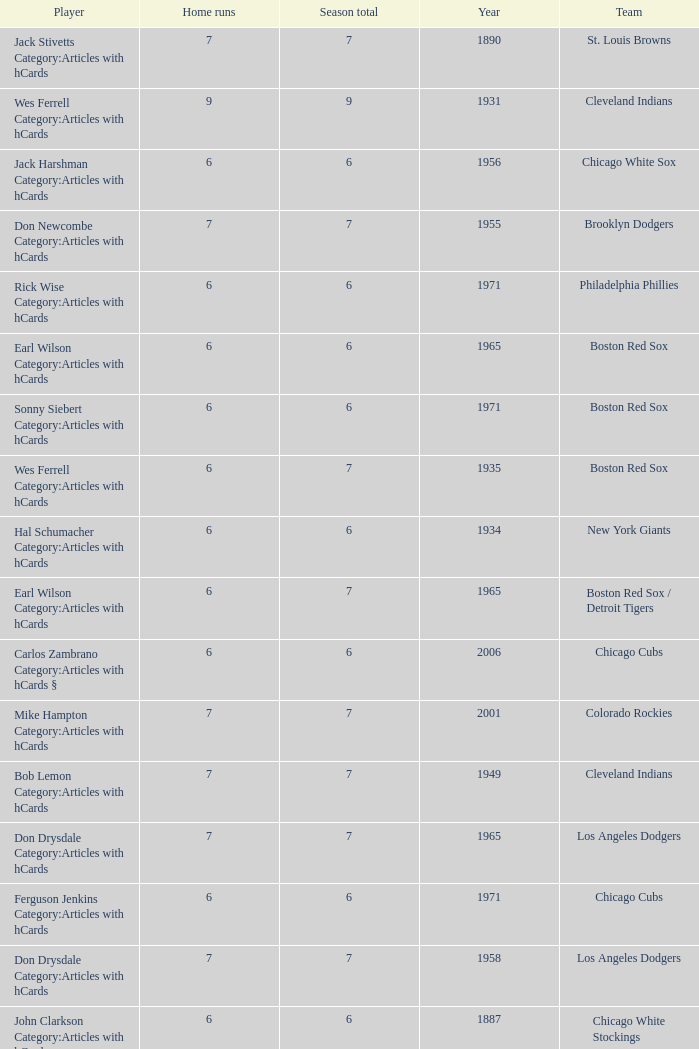Tell me the highest home runs for cleveland indians years before 1931 None. 